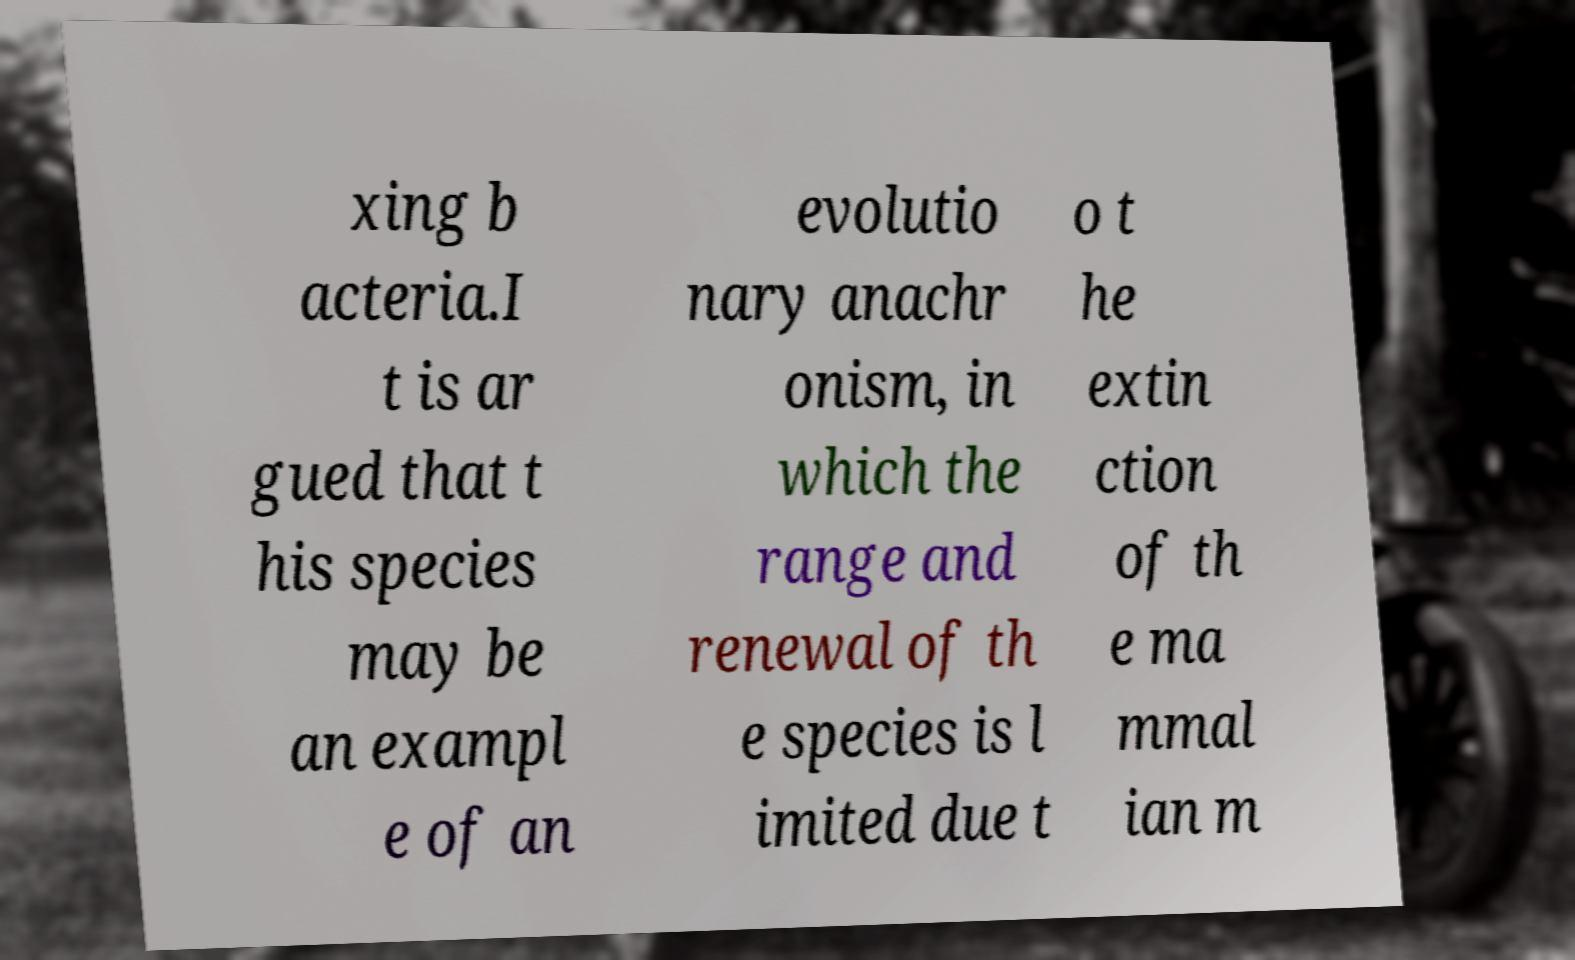Could you extract and type out the text from this image? xing b acteria.I t is ar gued that t his species may be an exampl e of an evolutio nary anachr onism, in which the range and renewal of th e species is l imited due t o t he extin ction of th e ma mmal ian m 